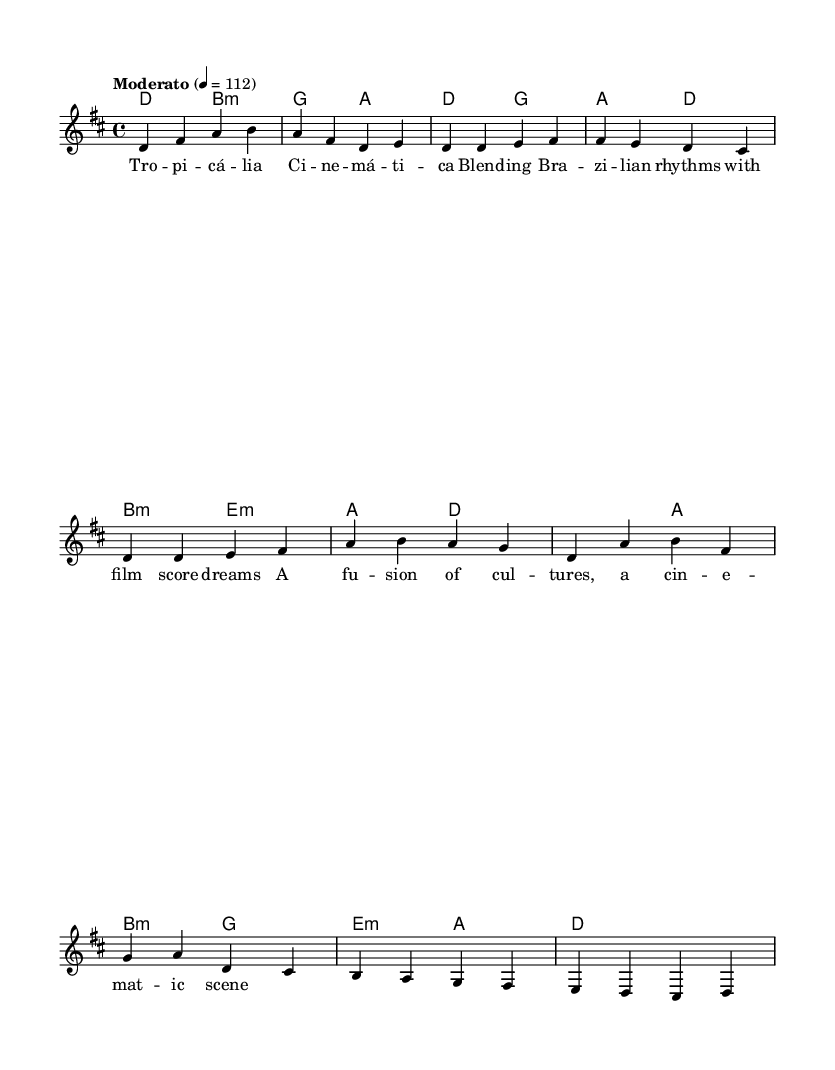What is the key signature of this music? The key signature indicates D major, which has two sharps (F# and C#). This can be inferred from the global section where the key is defined.
Answer: D major What is the time signature of this piece? The time signature is 4/4, as indicated at the beginning of the score in the global section. This means there are four beats in a measure.
Answer: 4/4 What is the tempo marking for this music? The tempo marking is "Moderato," which is noted in the global section, indicating a moderately paced tempo, usually around 108-120 beats per minute.
Answer: Moderato How many measures does the chorus section contain? The chorus section consists of four measures. By counting the measures in the chorus indicated in the melody part, we see there are four distinct groupings of notes.
Answer: 4 What musical genres are blended in this piece? The piece blends Brazilian rhythms with film score elements, as suggested by the title and the lyrics which refer to a "fusion of cultures." This suggests an integration of these styles.
Answer: Brazilian rhythms and film score Which chord is used at the beginning of the intro? The chord at the beginning of the intro is D major, identifiable from the chord section where it is the first chord listed.
Answer: D What is the lyric theme expressed in the piece? The theme expressed in the piece revolves around the fusion of cultures, particularly highlighting the blend of Brazilian music with cinematic elements, as articulated in the lyrics.
Answer: Fusion of cultures 